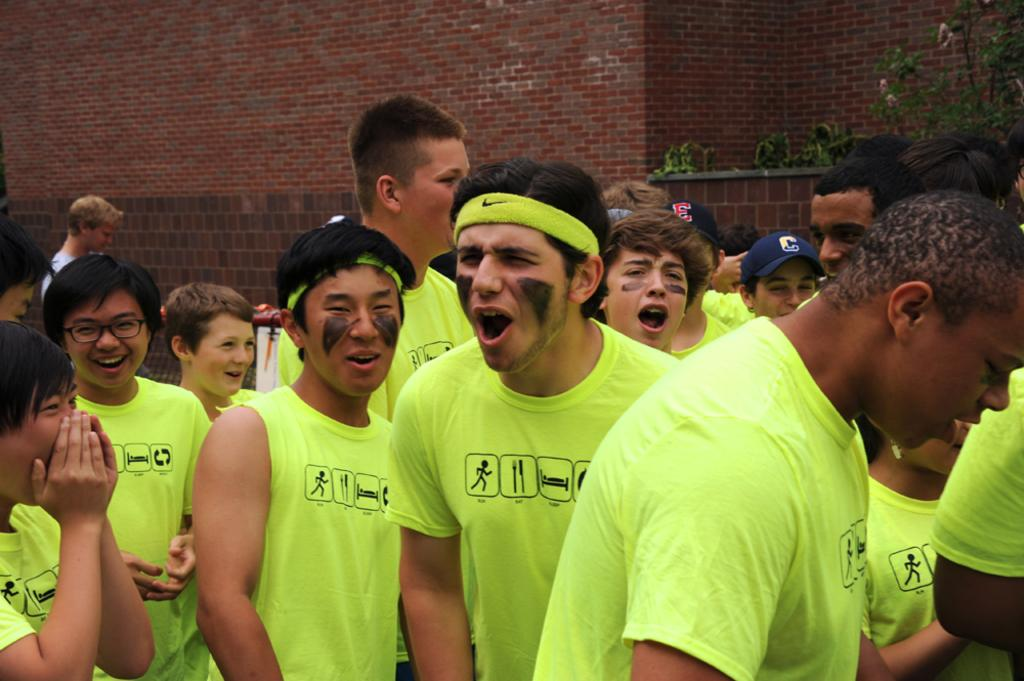Who or what is present in the image? There are people in the image. What are the people wearing? The people are wearing t-shirts. What can be seen in the background of the image? There are plants and a brick wall in the background of the image. How many jellyfish are swimming in the image? There are no jellyfish present in the image. What type of knot is being used to secure the people's clothing in the image? The people are wearing t-shirts, which do not require knots to secure them. 